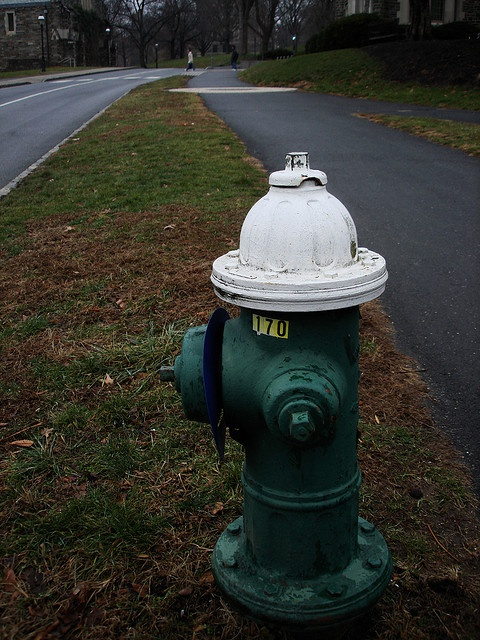Describe the objects in this image and their specific colors. I can see fire hydrant in gray, black, lightgray, teal, and darkgray tones, people in gray and black tones, and people in gray, black, and navy tones in this image. 